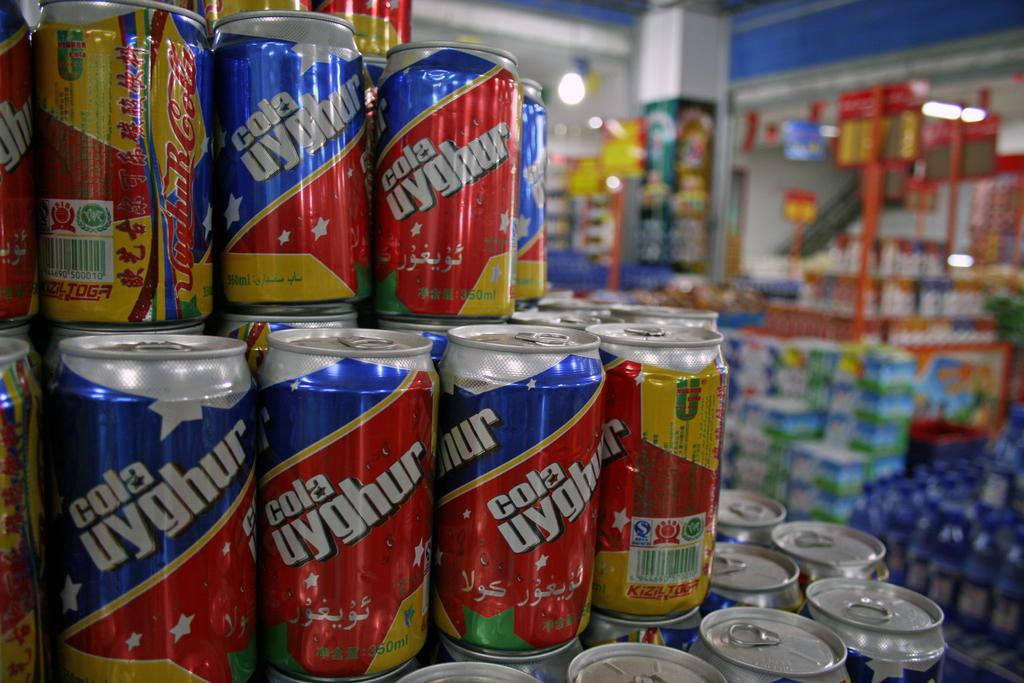<image>
Present a compact description of the photo's key features. A pyramid display of soda cans that say cola uyghur. 